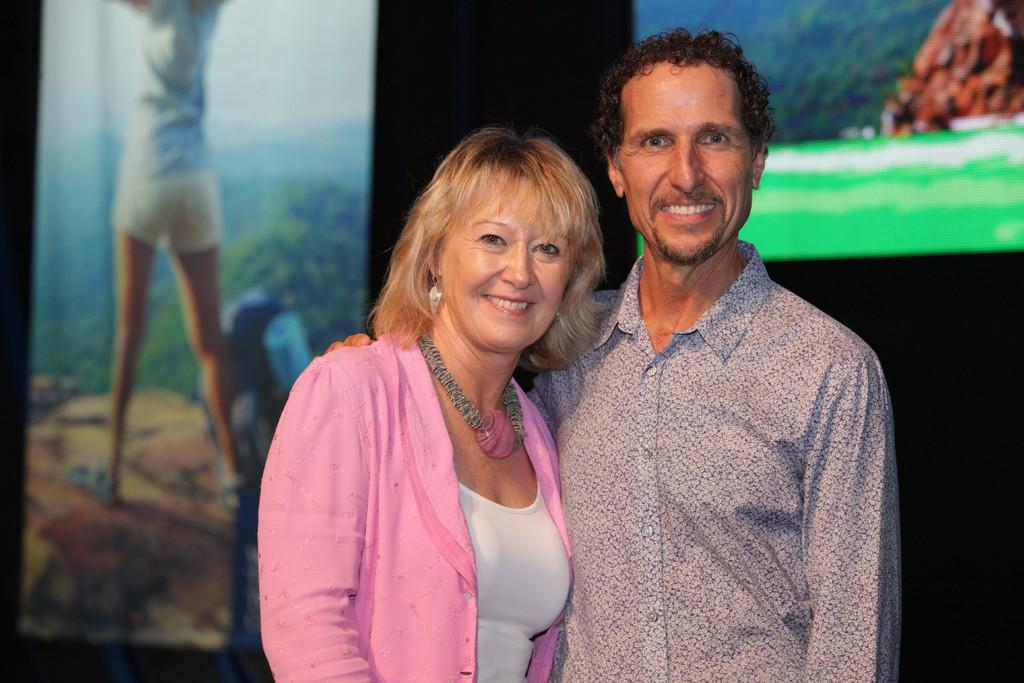How many people are in the image? There are two people in the image. What can be observed about the clothing of the people in the image? The people are wearing different color dresses. What objects can be seen in the image besides the people? Boards are visible in the image. What is the color of the background in the image? The background of the image is black. Is there a lamp illuminating the scene in the image? There is no lamp present in the image. What type of stone can be seen in the image? There is no stone visible in the image. 